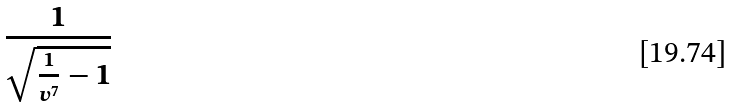<formula> <loc_0><loc_0><loc_500><loc_500>\frac { 1 } { \sqrt { \frac { 1 } { v ^ { 7 } } - 1 } }</formula> 